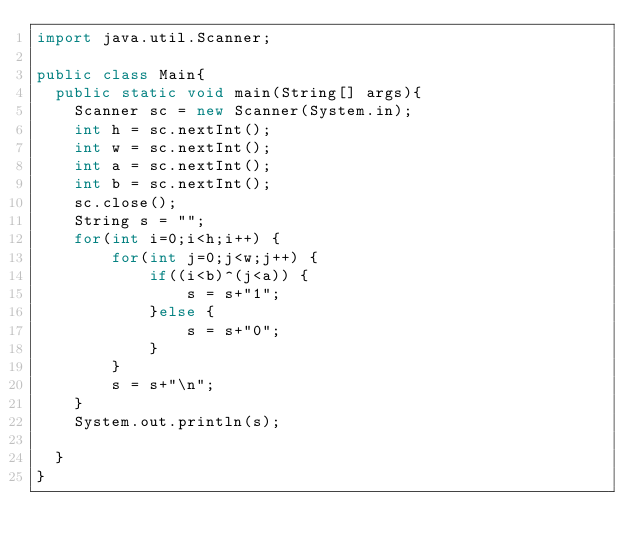Convert code to text. <code><loc_0><loc_0><loc_500><loc_500><_Java_>import java.util.Scanner;

public class Main{
  public static void main(String[] args){
    Scanner sc = new Scanner(System.in);
    int h = sc.nextInt();
    int w = sc.nextInt();
    int a = sc.nextInt();
    int b = sc.nextInt();
    sc.close();
    String s = "";
    for(int i=0;i<h;i++) {
    	for(int j=0;j<w;j++) {
    		if((i<b)^(j<a)) {
    			s = s+"1";
    		}else {
    			s = s+"0";
    		}
    	}
    	s = s+"\n";
    }
    System.out.println(s);
    
  }
}</code> 